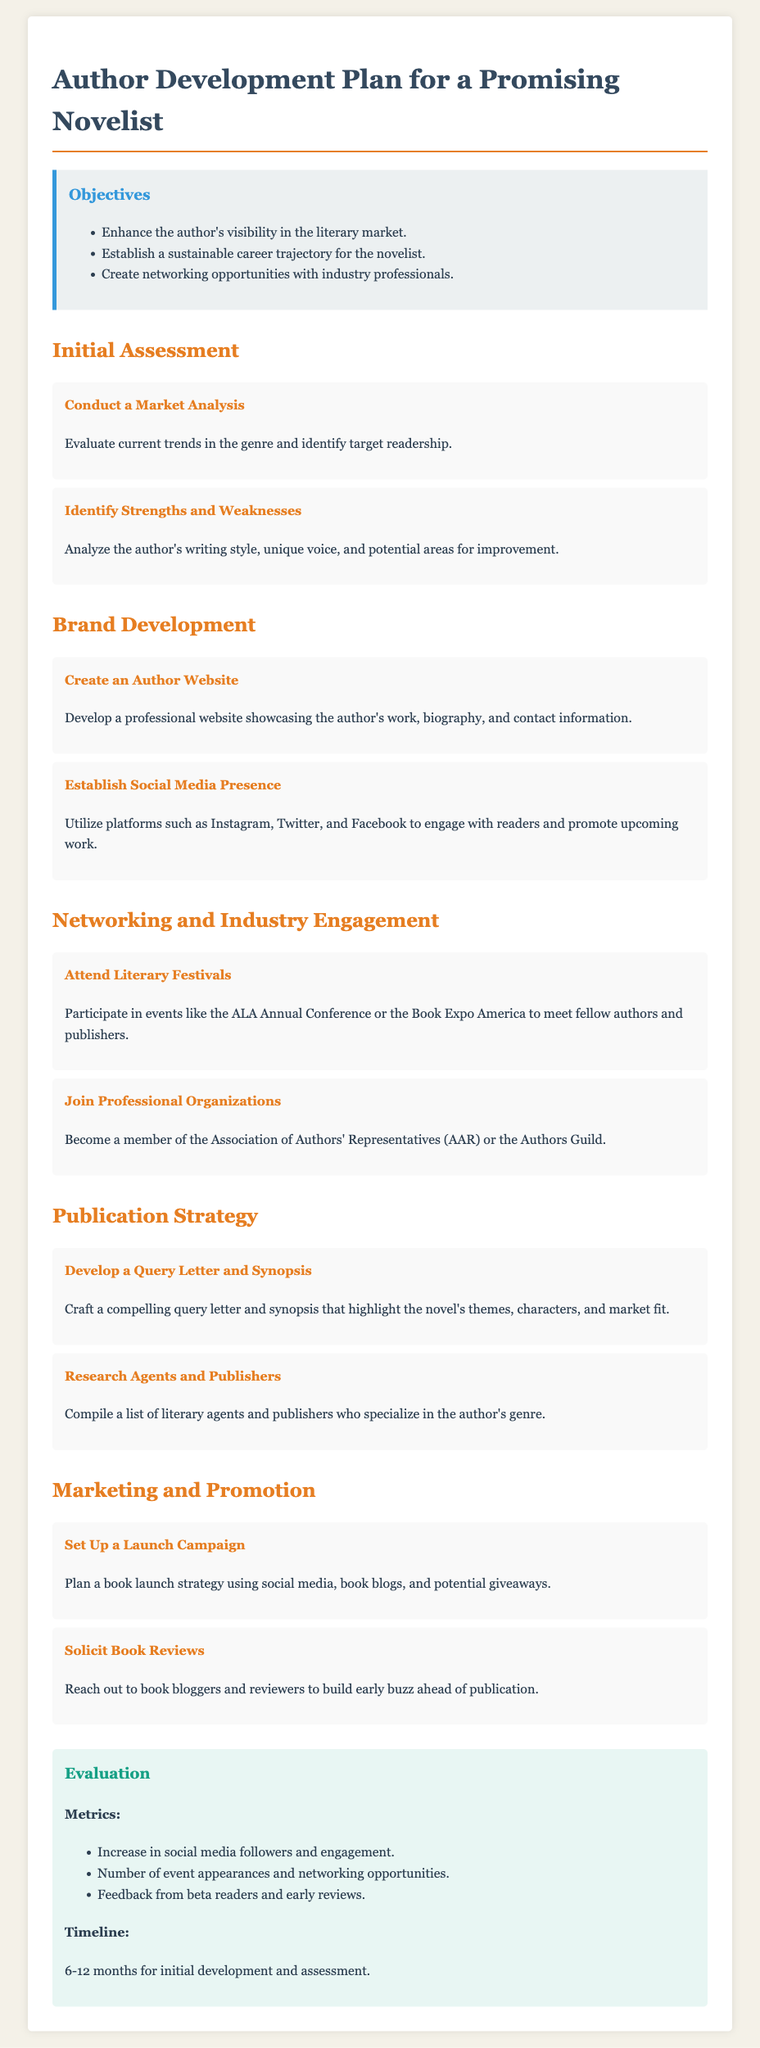What is the title of the document? The title is stated at the beginning of the document.
Answer: Author Development Plan for a Promising Novelist What are the three main objectives listed? The objectives are summarized in a bullet point list in the document.
Answer: Enhance the author's visibility in the literary market, Establish a sustainable career trajectory for the novelist, Create networking opportunities with industry professionals How many sections are there in the plan? The sections are distinctly headed in the document and can be counted.
Answer: Five What is the first activity in the Initial Assessment section? The first activity is listed among others in the Initial Assessment section.
Answer: Conduct a Market Analysis Which social media platforms are suggested for establishing a presence? The document mentions specific platforms in the Brand Development section.
Answer: Instagram, Twitter, and Facebook What is one metric listed for evaluation? The metrics are outlined in the evaluation section of the document.
Answer: Increase in social media followers and engagement What is the timeline for initial development and assessment? The timeline is specified in the evaluation section.
Answer: 6-12 months What event is recommended for networking? The activity is mentioned in the Networking and Industry Engagement section.
Answer: Literary Festivals What is the purpose of the Query Letter and Synopsis activity? The purpose is indicated in the description of the activity within the Publication Strategy section.
Answer: Highlight the novel's themes, characters, and market fit 